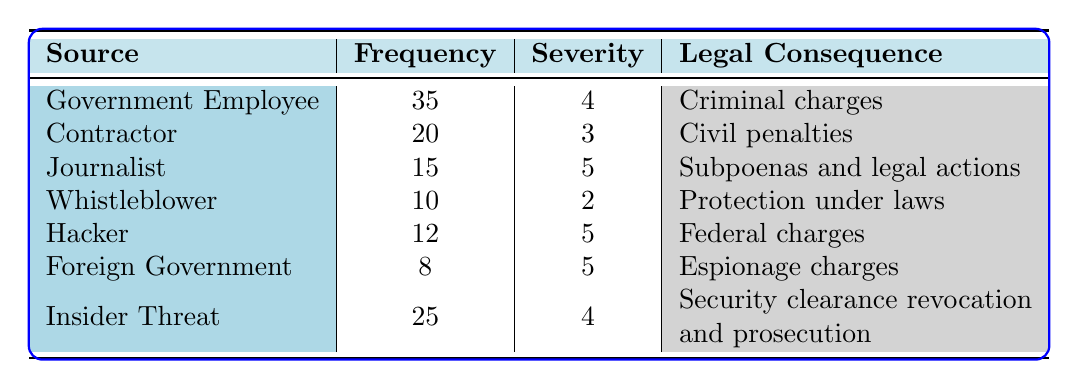What is the leak source with the highest frequency? From the table, I look for the row with the highest "Frequency" value. The "Government Employee" has a frequency of 35, which is greater than all other sources listed.
Answer: Government Employee What legal consequence is associated with a hacker leak? The table shows that the "Hacker" source corresponds to the legal consequence of "Federal charges."
Answer: Federal charges What is the total frequency of internal leak sources (Government Employee, Contractor, Insider Threat)? I sum the frequencies of the internal sources: 35 (Government Employee) + 20 (Contractor) + 25 (Insider Threat) = 80.
Answer: 80 Is the severity level for journalists higher than for whistleblowers? I compare the severity levels from the table: Journalist has a severity level of 5 and Whistleblower has a severity level of 2. Since 5 is greater than 2, the statement is true.
Answer: Yes Which leak source has the lowest severity level and what is the associated legal consequence? I look through the "Severity" column to find the lowest value, which is 2 for the "Whistleblower." The associated legal consequence from the table is "Protection under laws."
Answer: Whistleblower; Protection under laws What is the average severity level across all leak sources? I first find the severity levels: 4, 3, 5, 2, 5, 5, 4. The total sum of severity levels is 4 + 3 + 5 + 2 + 5 + 5 + 4 = 28. There are 7 sources, so I divide the total by 7: 28 / 7 = 4.
Answer: 4 Do any leak sources result in espionage charges? Checking the table, I see that the "Foreign Government" source indicates espionage charges as a legal consequence. Therefore, the answer is yes.
Answer: Yes What is the difference in frequency between the "Government Employee" and "Foreign Government" leak sources? I find the frequencies for both: Government Employee has 35 and Foreign Government has 8. The difference is calculated as 35 - 8 = 27.
Answer: 27 Which sources have a severity level of 5, and what are their legal consequences? I check the “Severity” column for the value 5. The sources are "Journalist," "Hacker," and "Foreign Government." Their legal consequences are "Subpoenas and legal actions," "Federal charges," and "Espionage charges," respectively.
Answer: Journalist: Subpoenas and legal actions; Hacker: Federal charges; Foreign Government: Espionage charges 